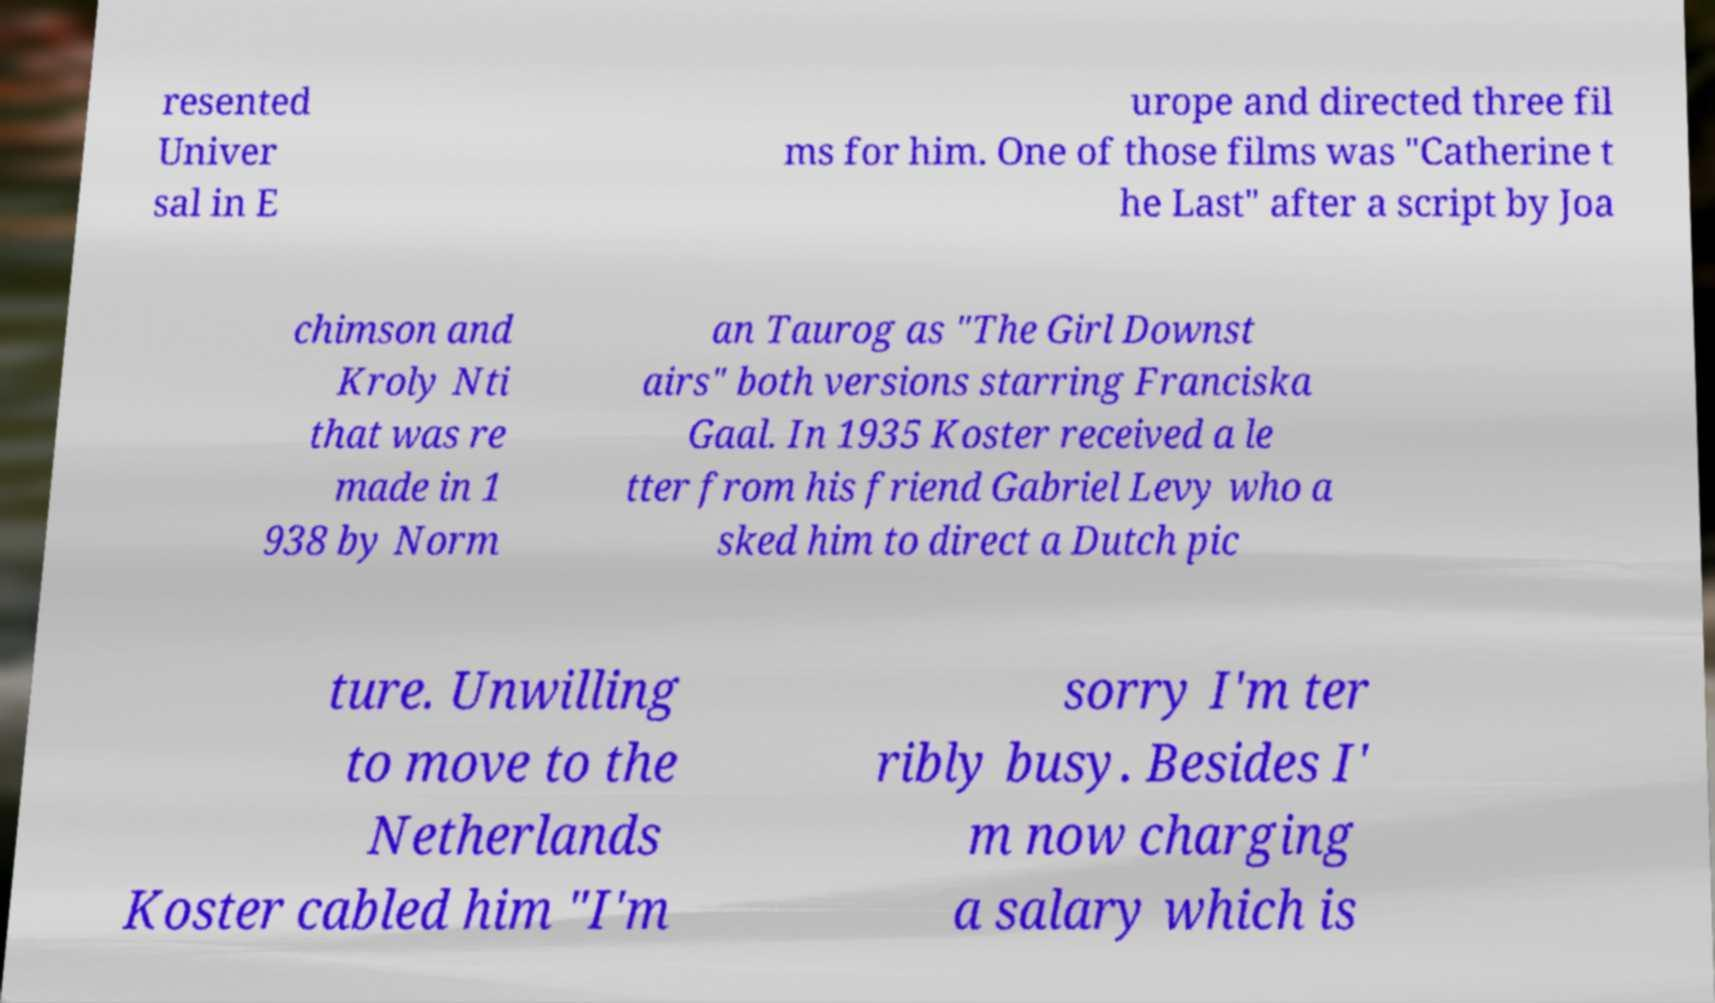What messages or text are displayed in this image? I need them in a readable, typed format. resented Univer sal in E urope and directed three fil ms for him. One of those films was "Catherine t he Last" after a script by Joa chimson and Kroly Nti that was re made in 1 938 by Norm an Taurog as "The Girl Downst airs" both versions starring Franciska Gaal. In 1935 Koster received a le tter from his friend Gabriel Levy who a sked him to direct a Dutch pic ture. Unwilling to move to the Netherlands Koster cabled him "I'm sorry I'm ter ribly busy. Besides I' m now charging a salary which is 